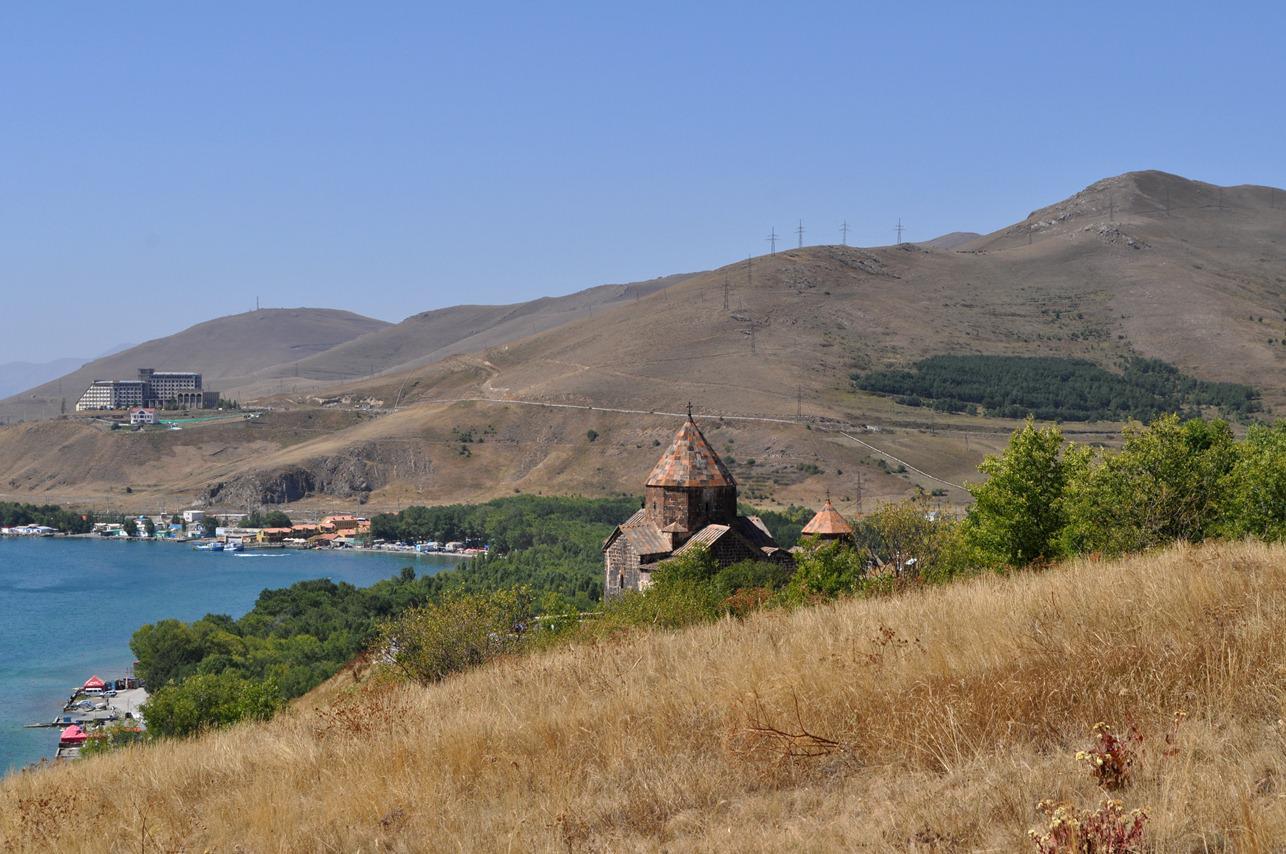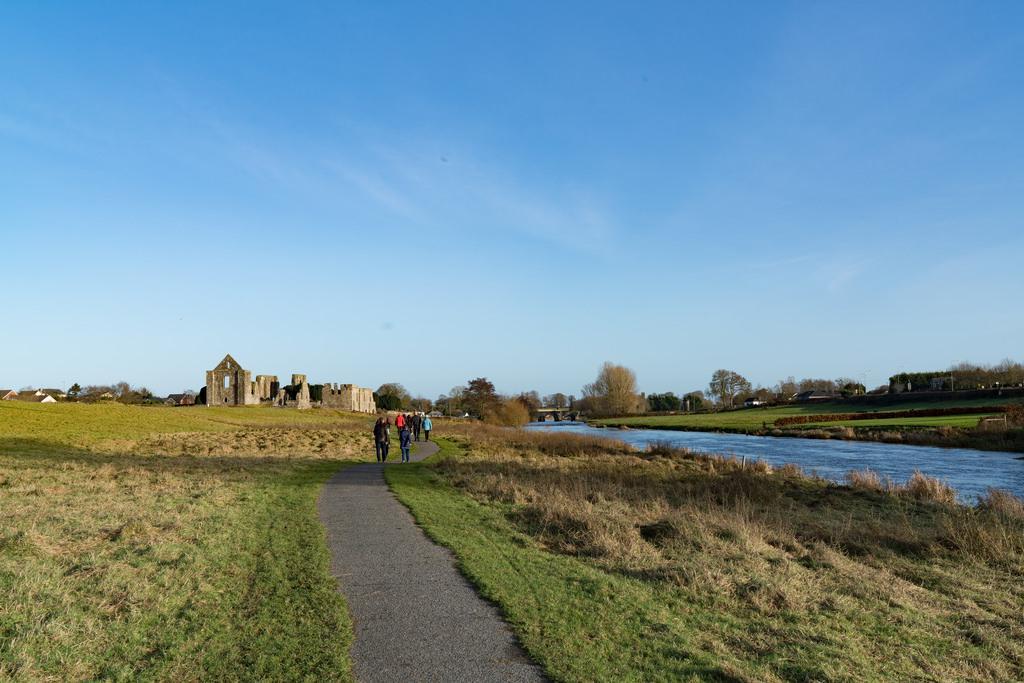The first image is the image on the left, the second image is the image on the right. Examine the images to the left and right. Is the description "The building in one of the images is near a body of water." accurate? Answer yes or no. Yes. The first image is the image on the left, the second image is the image on the right. For the images shown, is this caption "The nearest end wall of ancient stone church ruins rises to a triangular point with a large window opening placed directly under the point." true? Answer yes or no. No. 